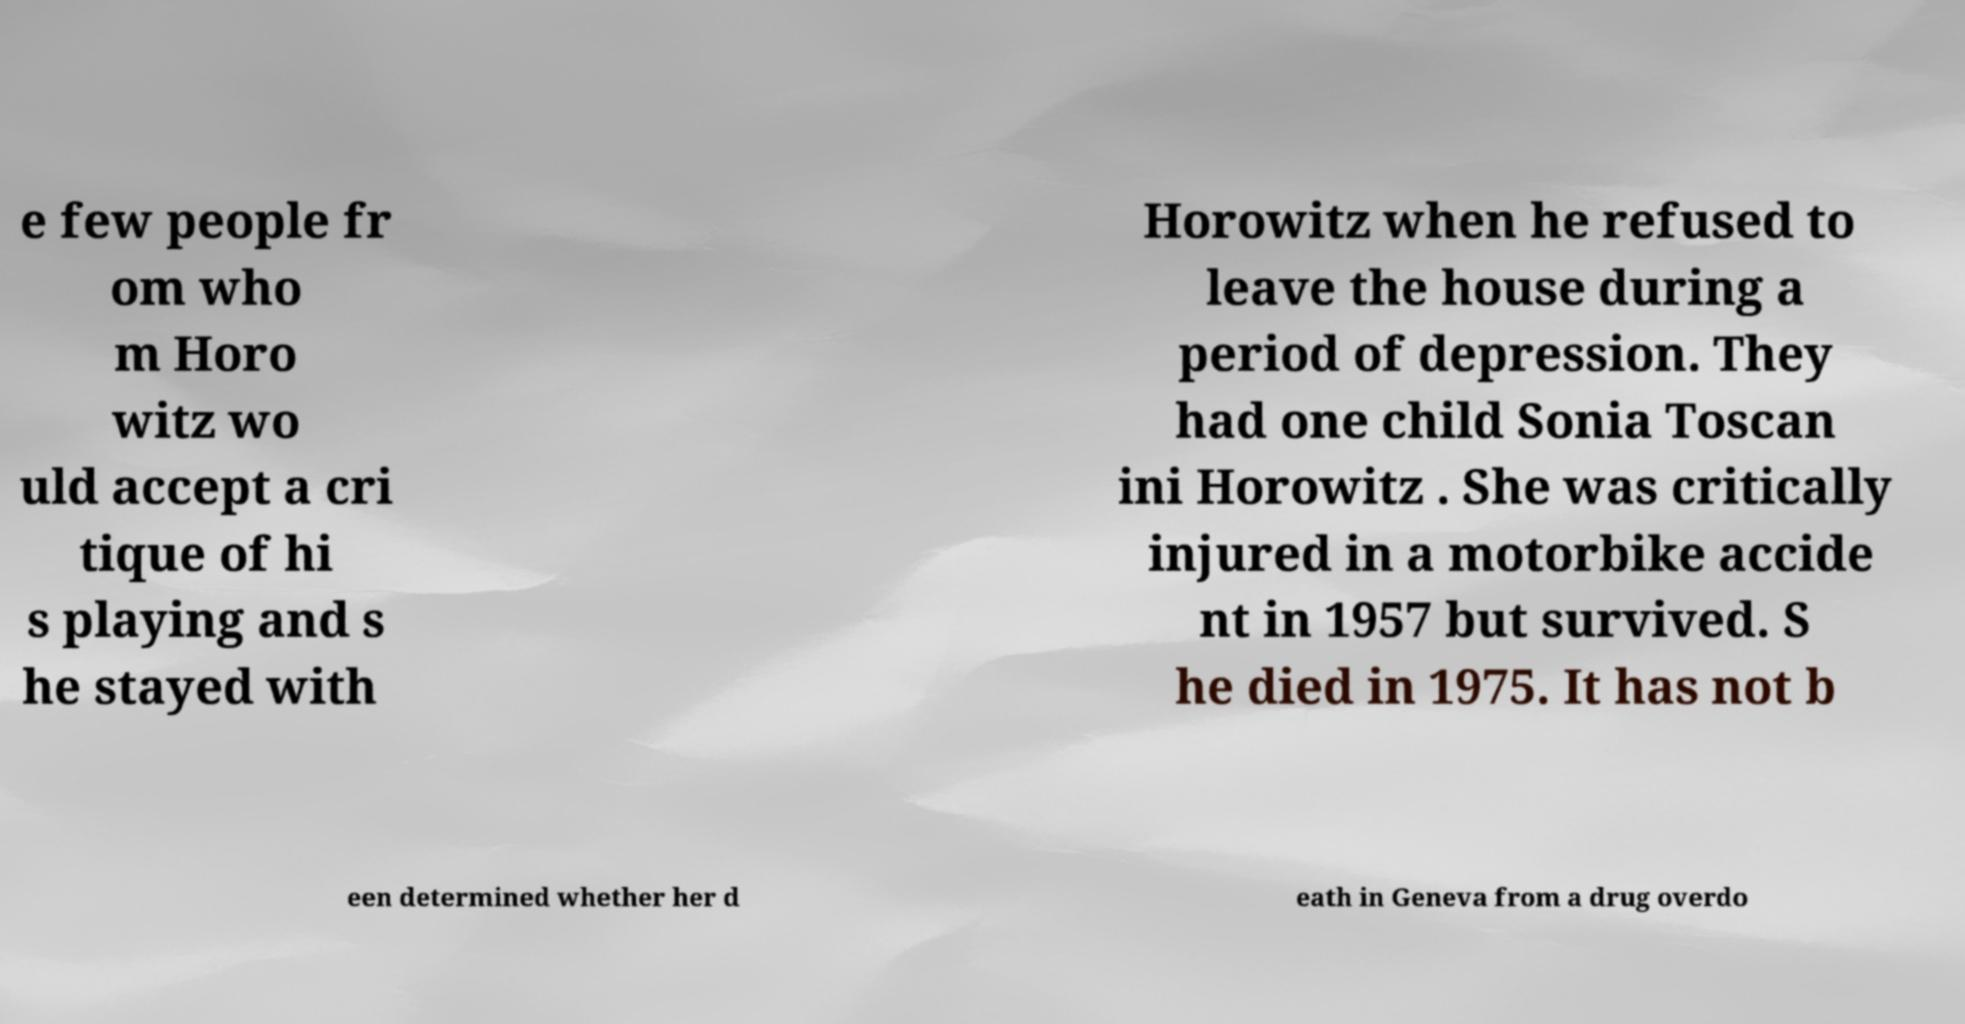Could you extract and type out the text from this image? e few people fr om who m Horo witz wo uld accept a cri tique of hi s playing and s he stayed with Horowitz when he refused to leave the house during a period of depression. They had one child Sonia Toscan ini Horowitz . She was critically injured in a motorbike accide nt in 1957 but survived. S he died in 1975. It has not b een determined whether her d eath in Geneva from a drug overdo 